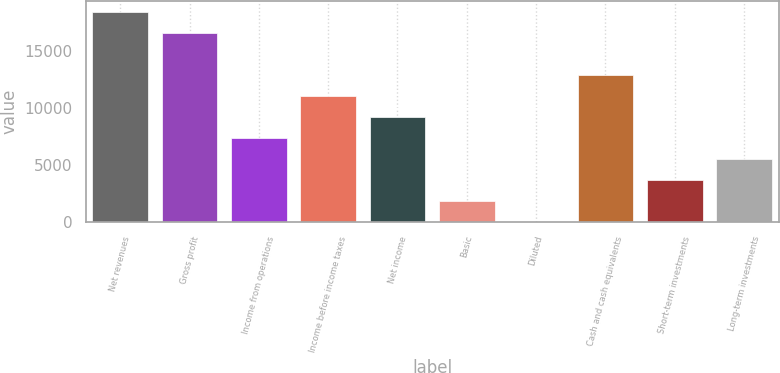<chart> <loc_0><loc_0><loc_500><loc_500><bar_chart><fcel>Net revenues<fcel>Gross profit<fcel>Income from operations<fcel>Income before income taxes<fcel>Net income<fcel>Basic<fcel>Diluted<fcel>Cash and cash equivalents<fcel>Short-term investments<fcel>Long-term investments<nl><fcel>18408<fcel>16567.4<fcel>7364.31<fcel>11045.5<fcel>9204.93<fcel>1842.45<fcel>1.83<fcel>12886.2<fcel>3683.07<fcel>5523.69<nl></chart> 